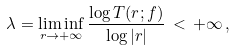Convert formula to latex. <formula><loc_0><loc_0><loc_500><loc_500>\lambda = \liminf _ { r \to + \infty } \frac { \log T ( r ; f ) } { \log | r | } \, < \, + \infty \, ,</formula> 